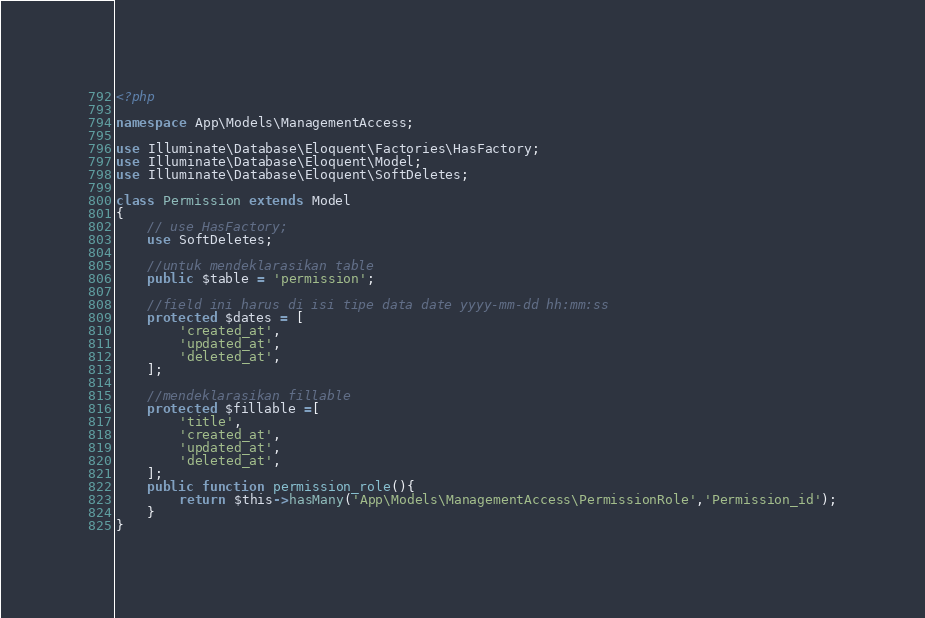Convert code to text. <code><loc_0><loc_0><loc_500><loc_500><_PHP_><?php

namespace App\Models\ManagementAccess;

use Illuminate\Database\Eloquent\Factories\HasFactory;
use Illuminate\Database\Eloquent\Model;
use Illuminate\Database\Eloquent\SoftDeletes;

class Permission extends Model
{
    // use HasFactory;
    use SoftDeletes;

    //untuk mendeklarasikan table
    public $table = 'permission';

    //field ini harus di isi tipe data date yyyy-mm-dd hh:mm:ss
    protected $dates = [
        'created_at',
        'updated_at',
        'deleted_at',
    ];

    //mendeklarasikan fillable
    protected $fillable =[
        'title',
        'created_at',
        'updated_at',
        'deleted_at',
    ];
    public function permission_role(){
        return $this->hasMany('App\Models\ManagementAccess\PermissionRole','Permission_id');
    }
}
</code> 